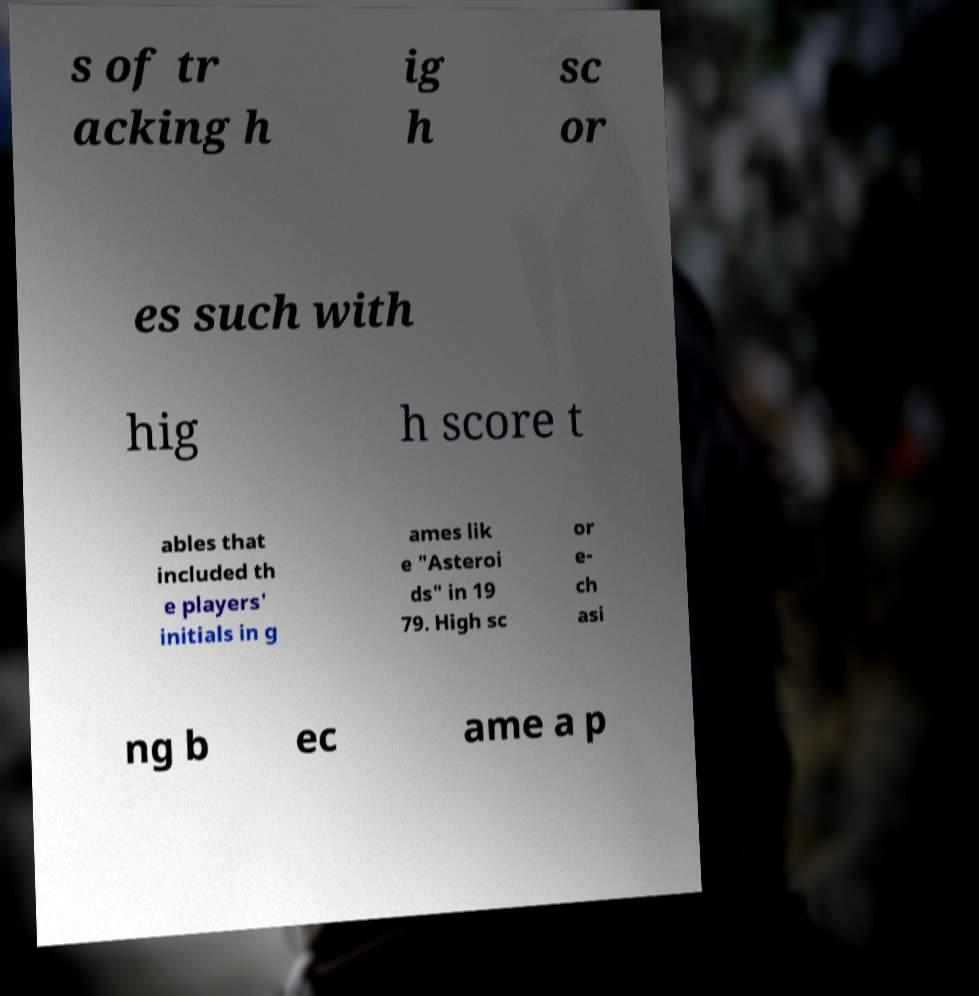Please identify and transcribe the text found in this image. s of tr acking h ig h sc or es such with hig h score t ables that included th e players' initials in g ames lik e "Asteroi ds" in 19 79. High sc or e- ch asi ng b ec ame a p 